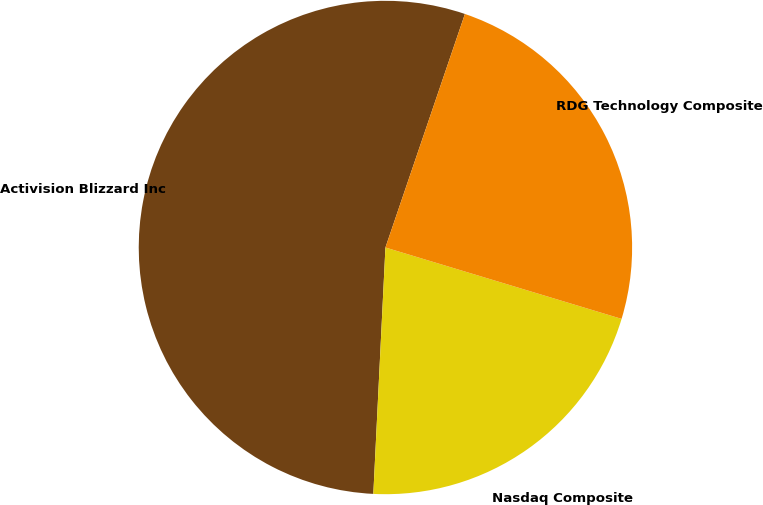Convert chart. <chart><loc_0><loc_0><loc_500><loc_500><pie_chart><fcel>Activision Blizzard Inc<fcel>Nasdaq Composite<fcel>RDG Technology Composite<nl><fcel>54.44%<fcel>21.11%<fcel>24.45%<nl></chart> 